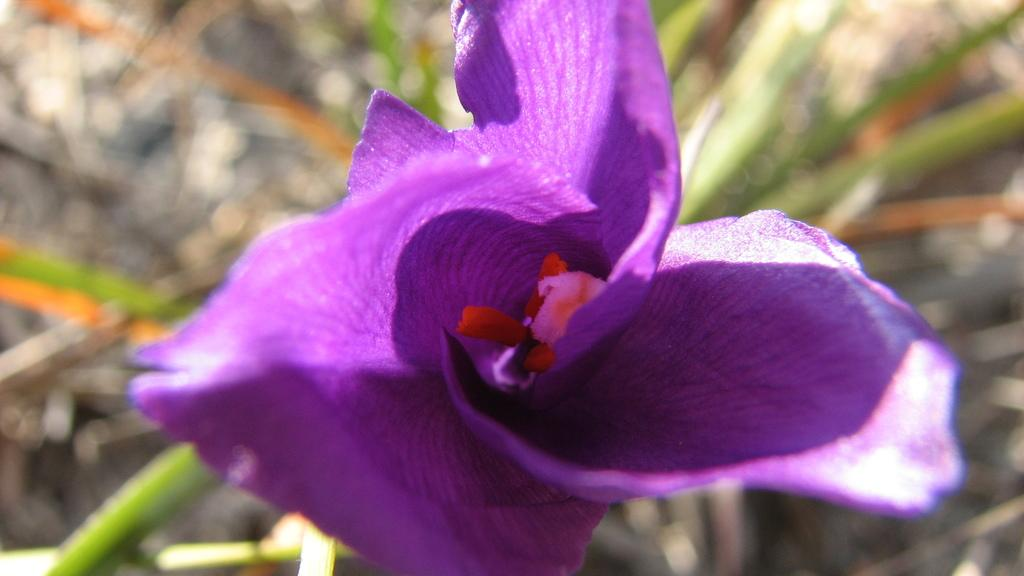What type of flower is in the image? There is a purple color flower in the image. Can you describe the background of the image? The background of the image is blurred. What type of milk is being poured into the book in the image? There is no milk or book present in the image; it only features a purple color flower with a blurred background. 